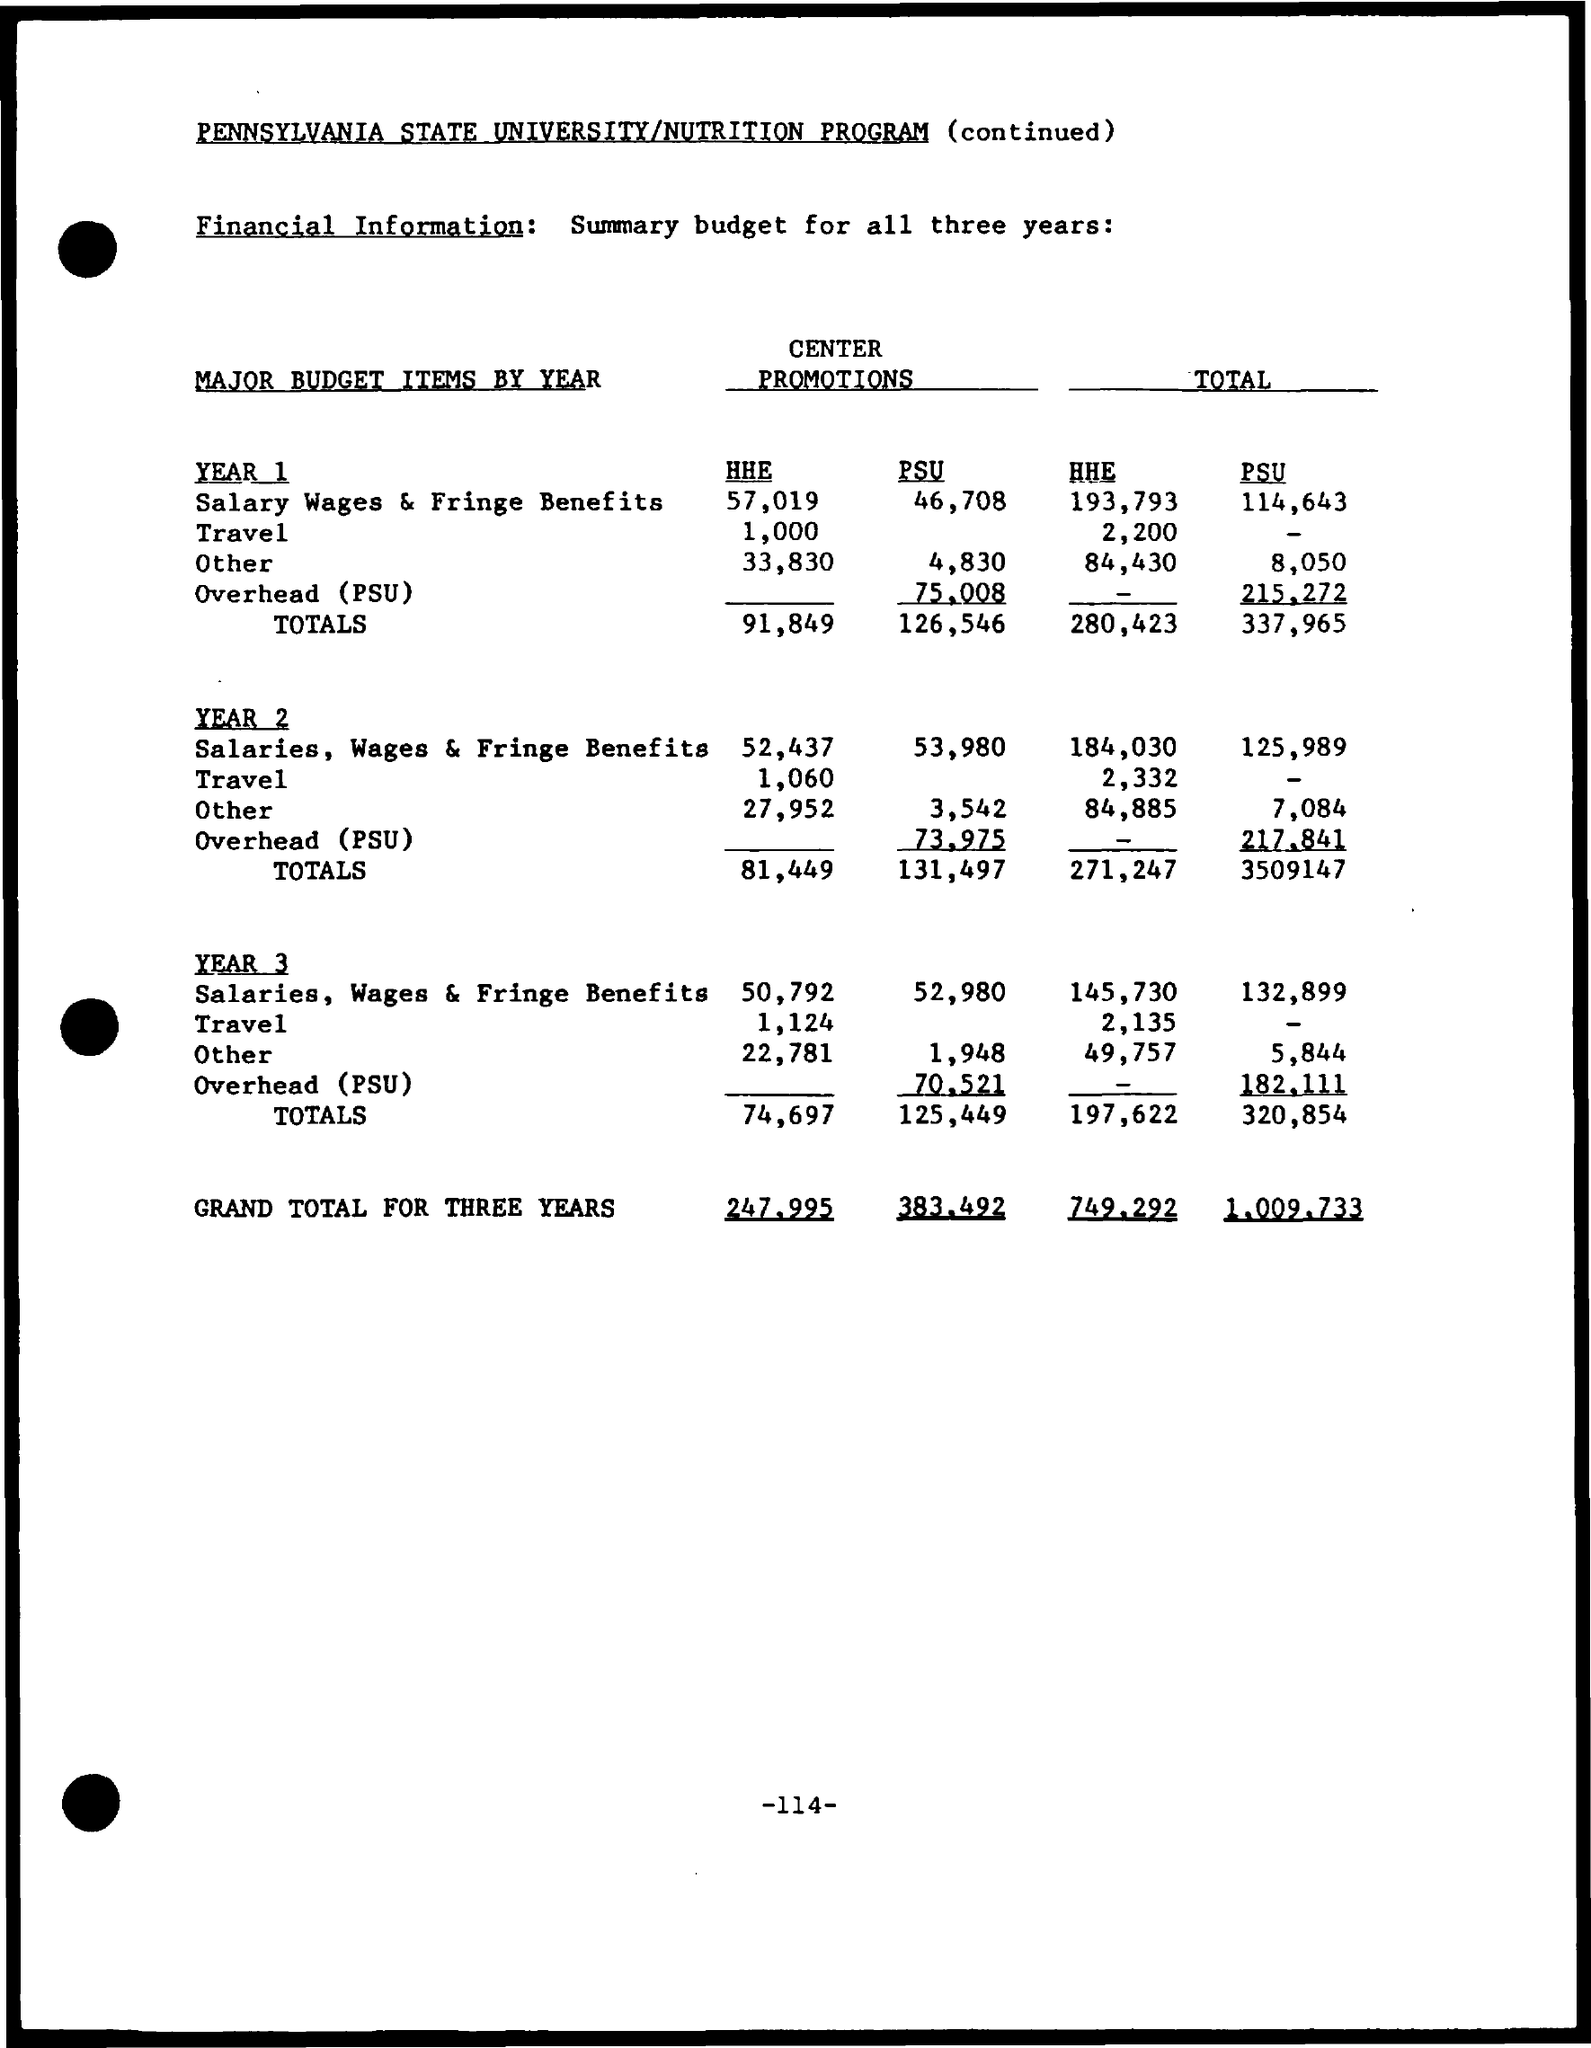Mention a couple of crucial points in this snapshot. The total travel for the HHE for year 2 is 2,332. The total other expenses for PSU for Year 1 is 8,050. The total salary wages and fringe benefits for a PSU for year 1 is 114,643. The total other expenses for HHE for Year 2 is 84,885. The total salary wages and fringe benefits for HHE for Year 2 is 184,030. 